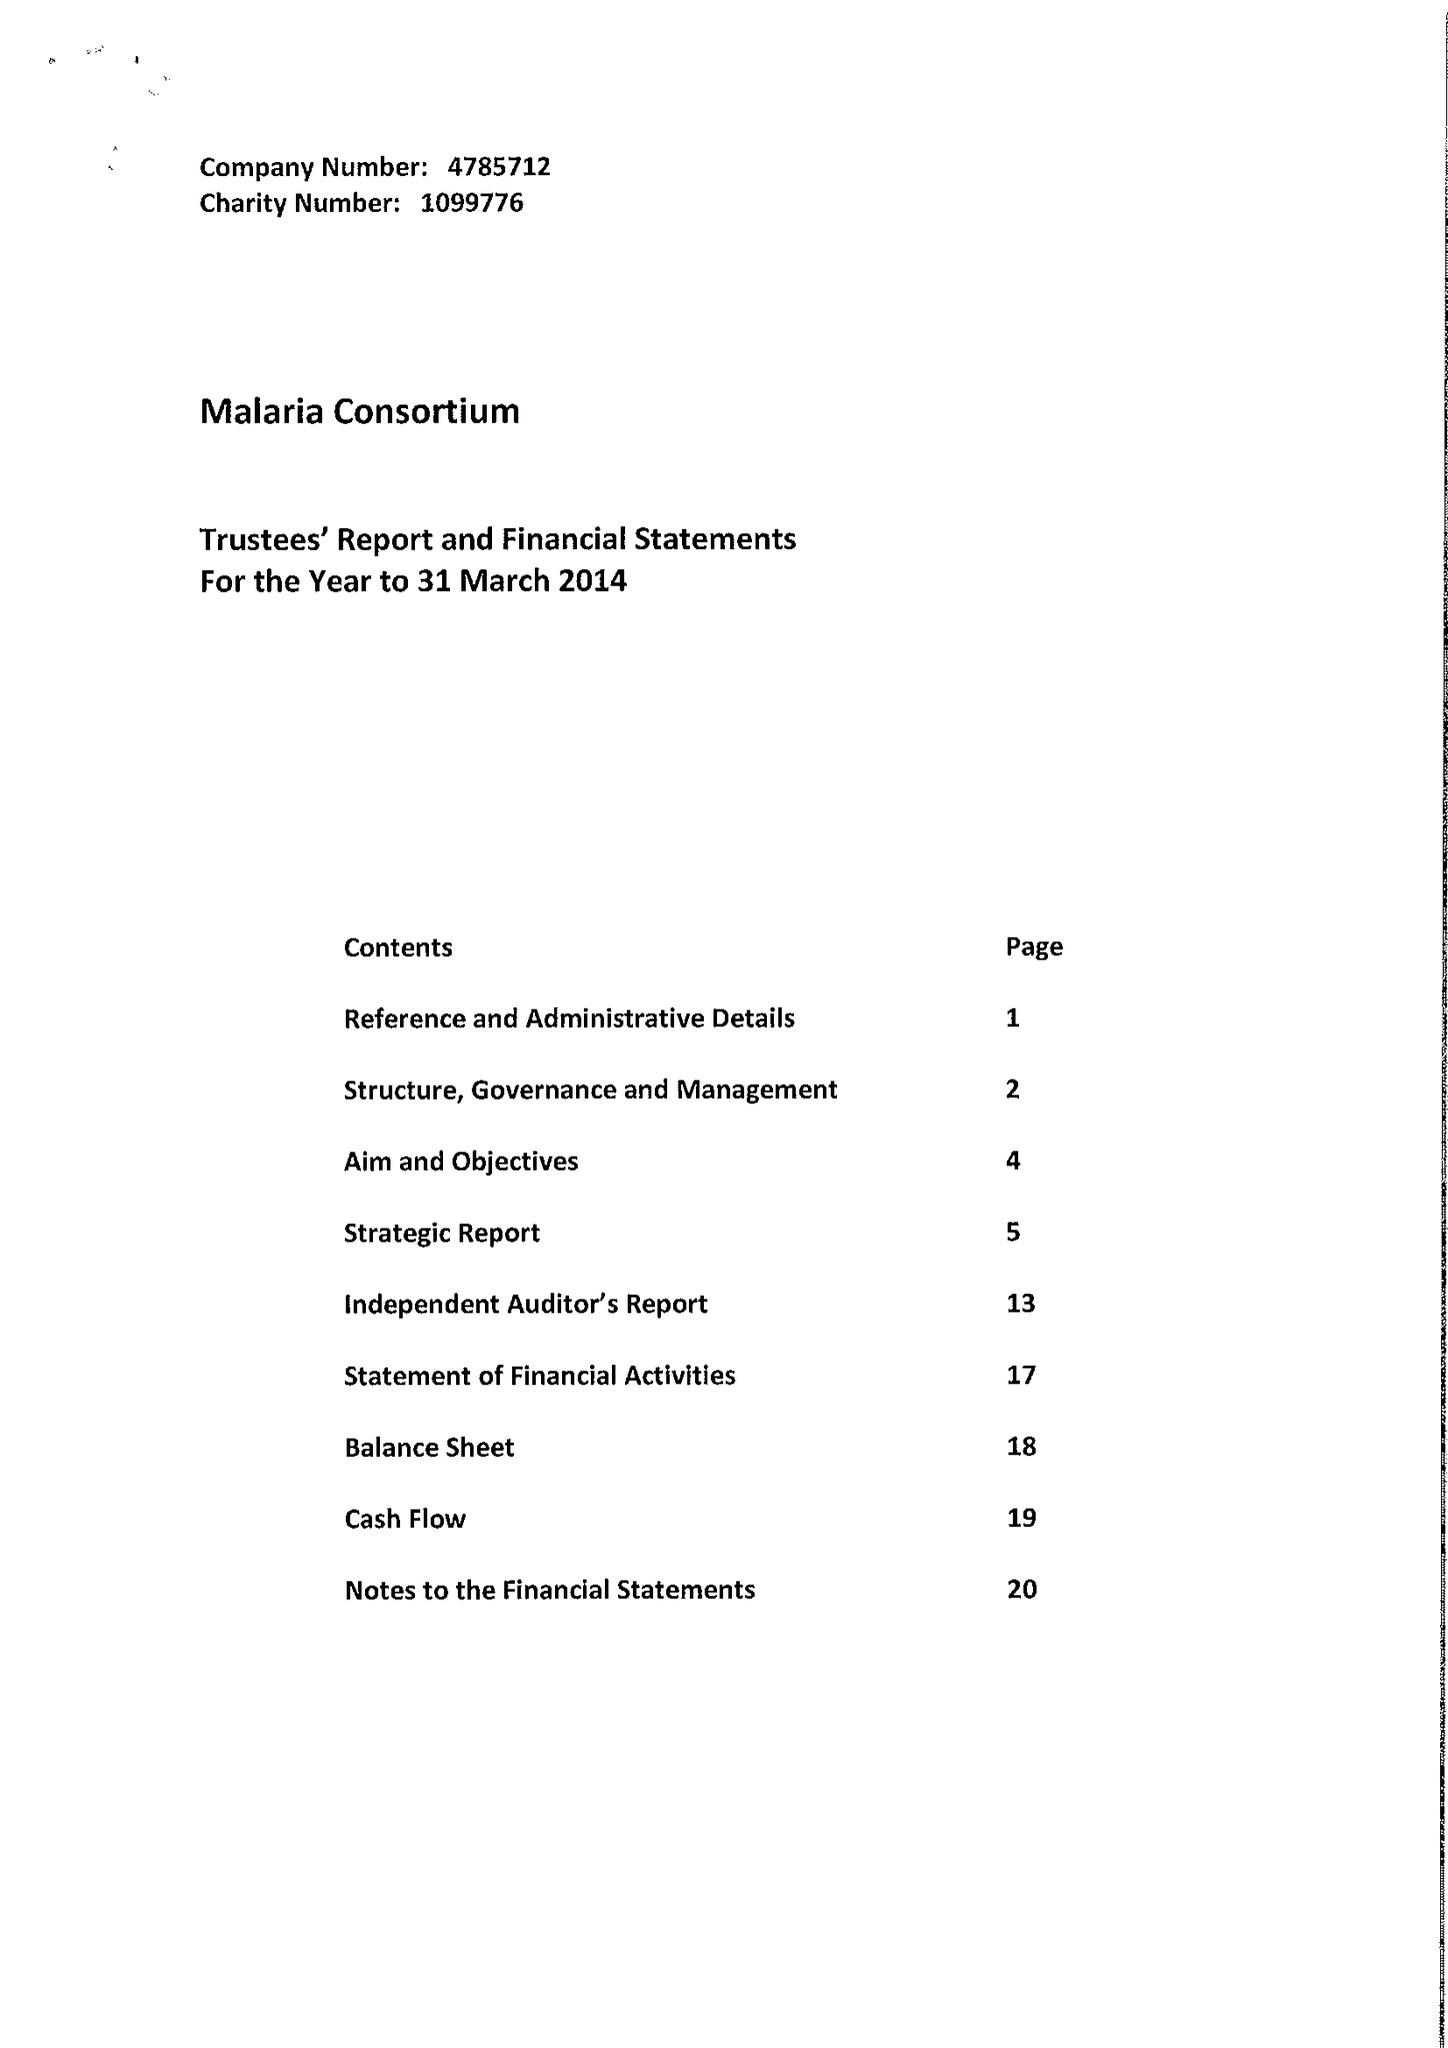What is the value for the charity_number?
Answer the question using a single word or phrase. 1099776 